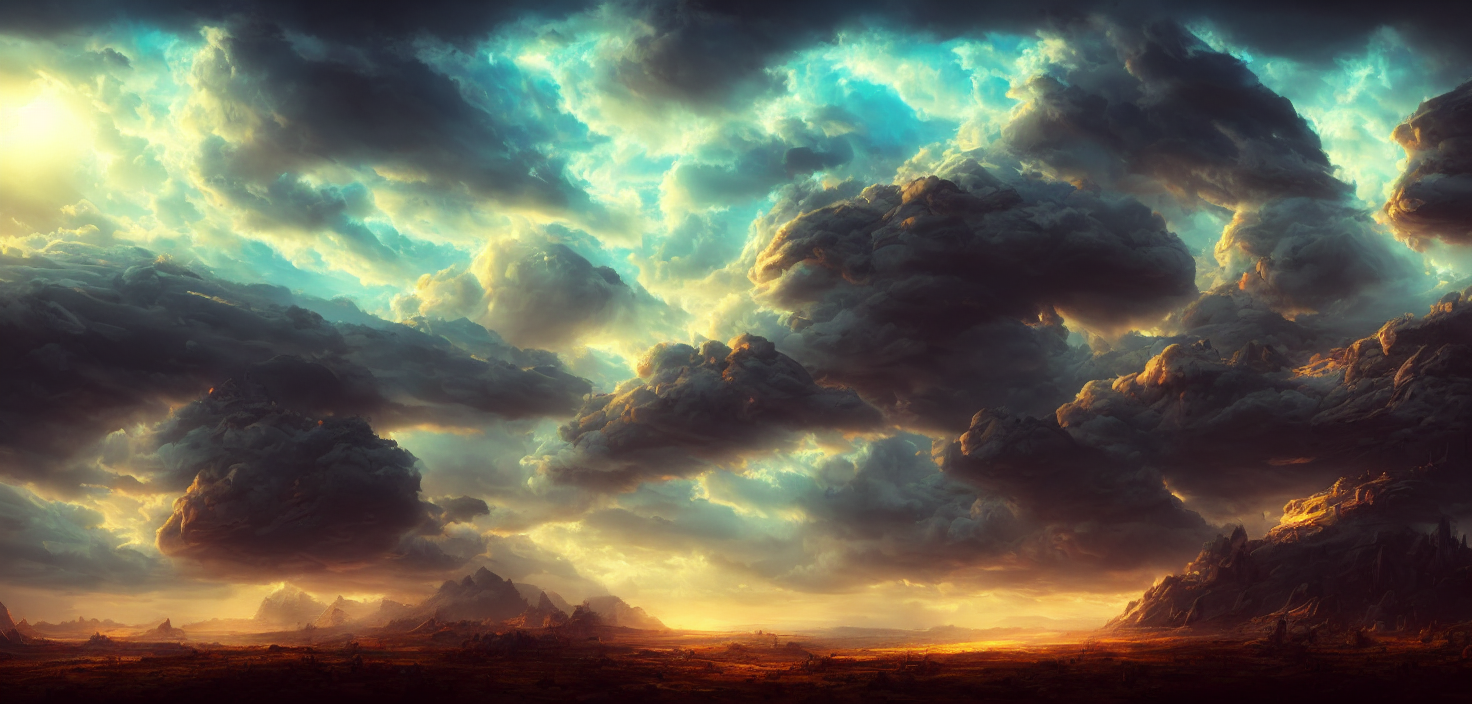Are the background details easy to identify?
A. Easy to identify
B. Blend with the main subject
C. Clear and identifiable
D. Difficult to identify
Answer with the option's letter from the given choices directly. The background details in the image are C. Clear and identifiable. The dramatic sky, with its dynamic and contrasting clouds, immediately catches the eye, and the distant landscape features distinct silhouettes, allowing for clear identification of the elements present in the scenery. 